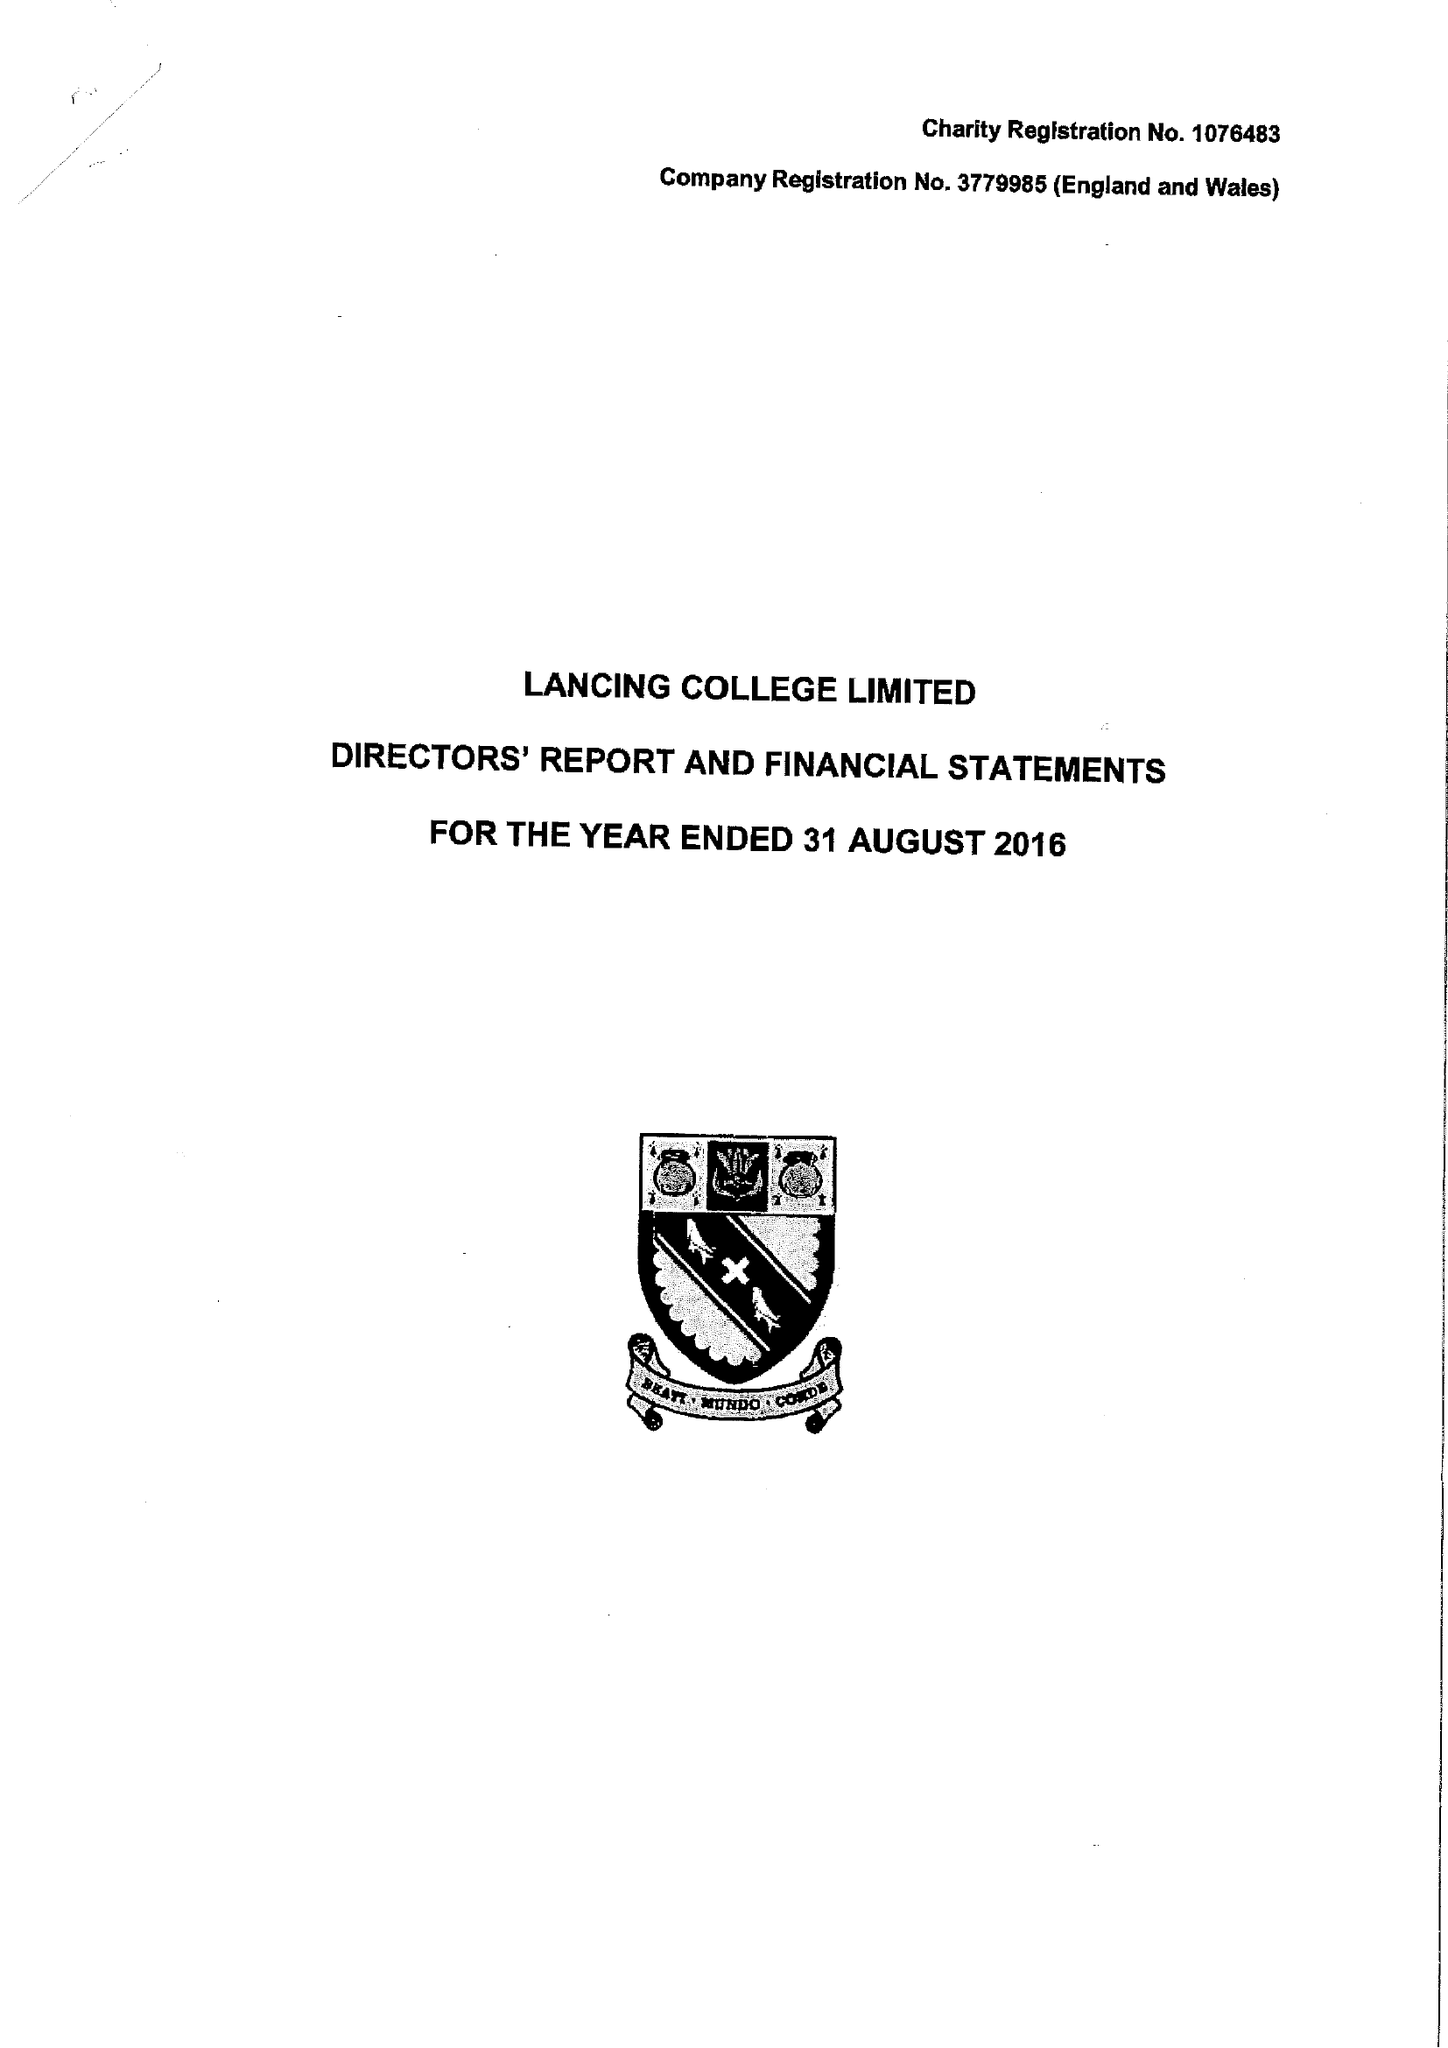What is the value for the charity_number?
Answer the question using a single word or phrase. 1076483 